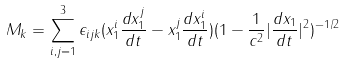Convert formula to latex. <formula><loc_0><loc_0><loc_500><loc_500>M _ { k } = \sum _ { i , j = 1 } ^ { 3 } \epsilon _ { i j k } ( x _ { 1 } ^ { i } \frac { d x _ { 1 } ^ { j } } { d t } - x _ { 1 } ^ { j } \frac { d x _ { 1 } ^ { i } } { d t } ) ( 1 - \frac { 1 } { c ^ { 2 } } | \frac { d { x } _ { 1 } } { d t } | ^ { 2 } ) ^ { - 1 / 2 }</formula> 